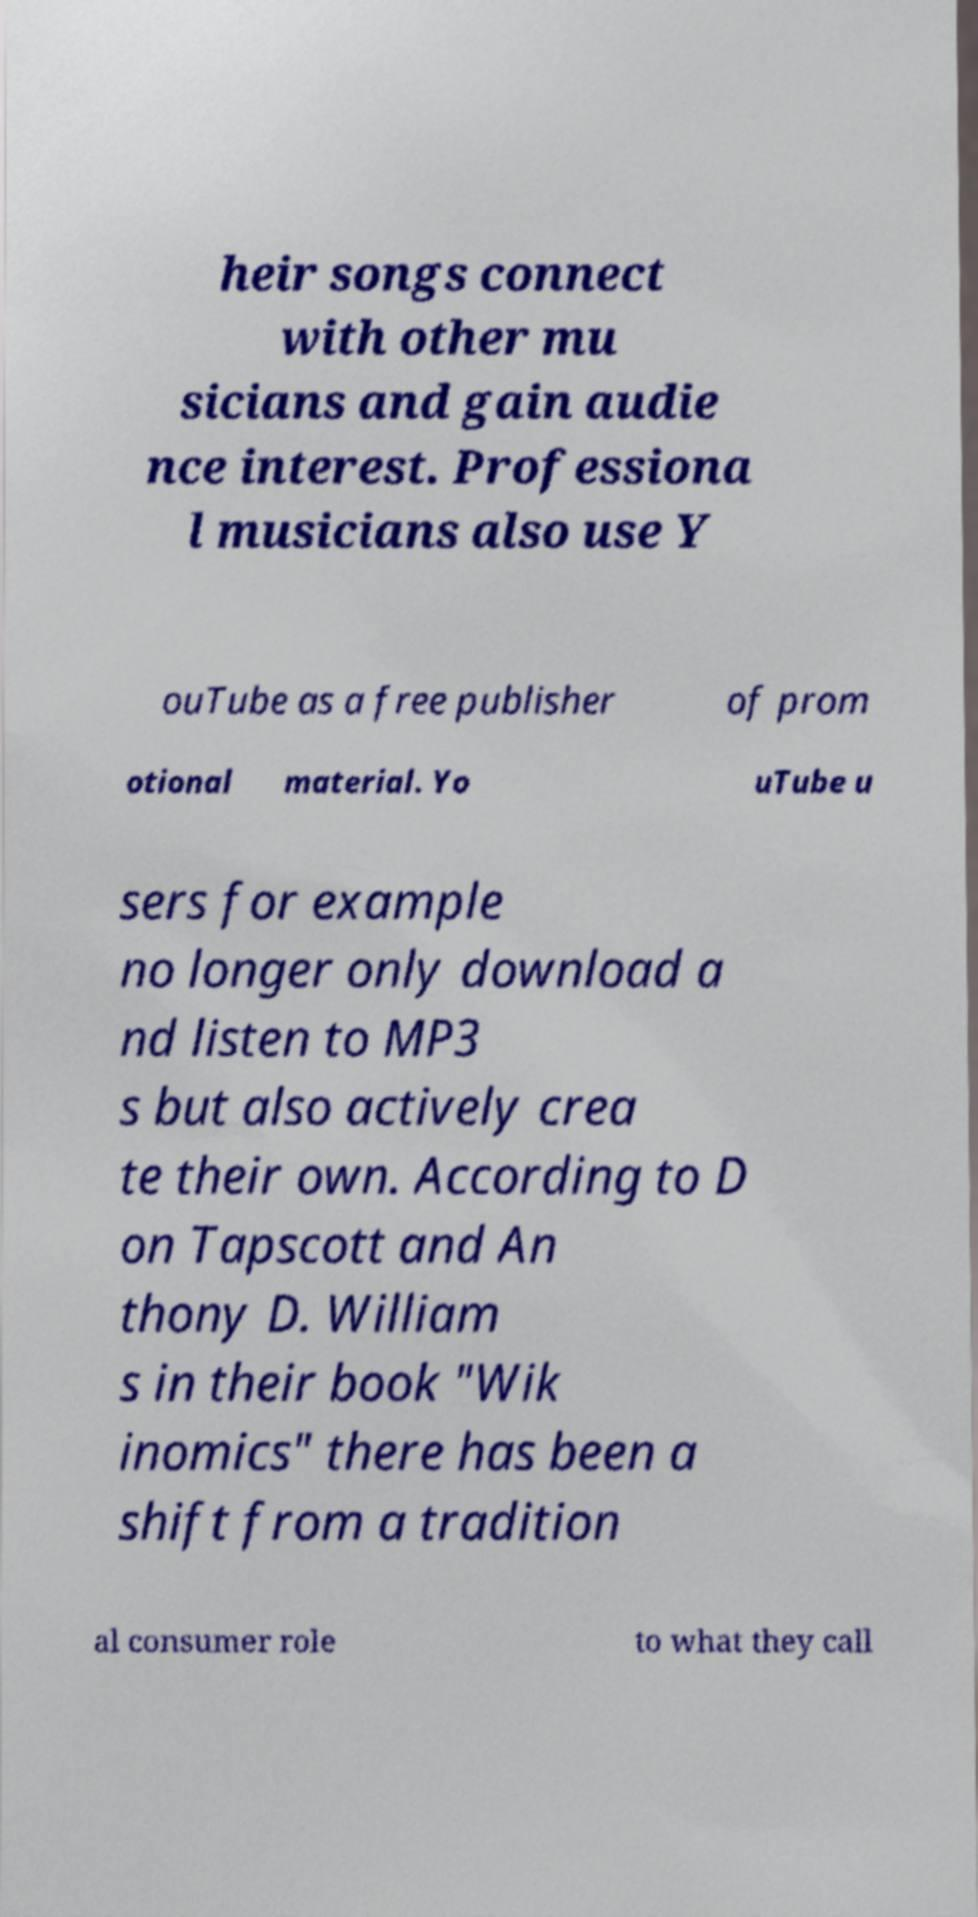There's text embedded in this image that I need extracted. Can you transcribe it verbatim? heir songs connect with other mu sicians and gain audie nce interest. Professiona l musicians also use Y ouTube as a free publisher of prom otional material. Yo uTube u sers for example no longer only download a nd listen to MP3 s but also actively crea te their own. According to D on Tapscott and An thony D. William s in their book "Wik inomics" there has been a shift from a tradition al consumer role to what they call 